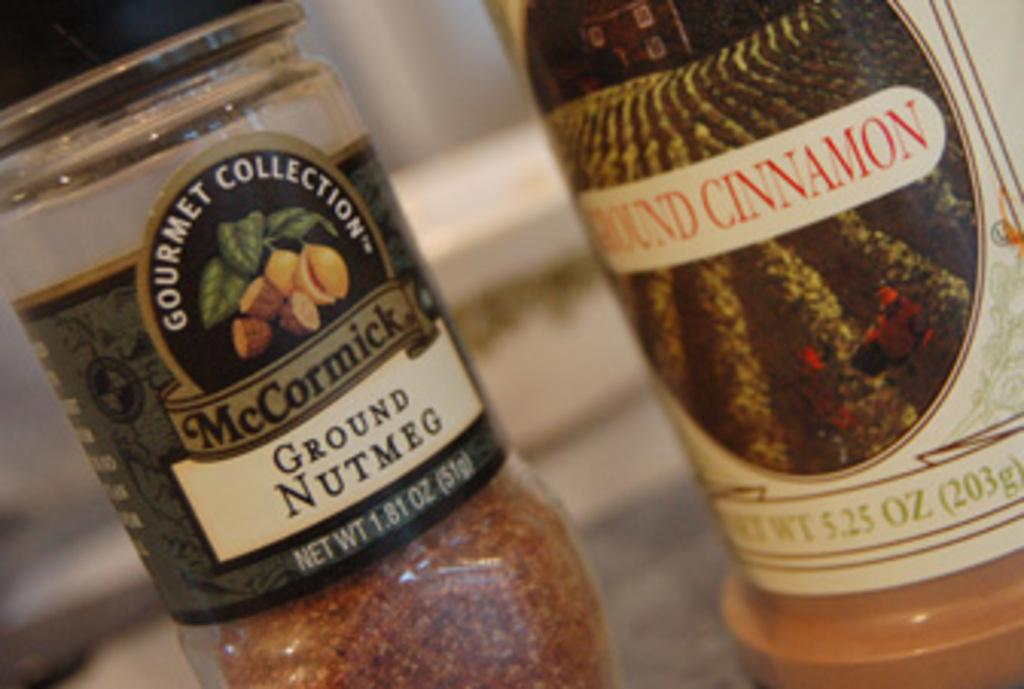<image>
Describe the image concisely. a spice bottle labeled as mccormick ground nutmeg 